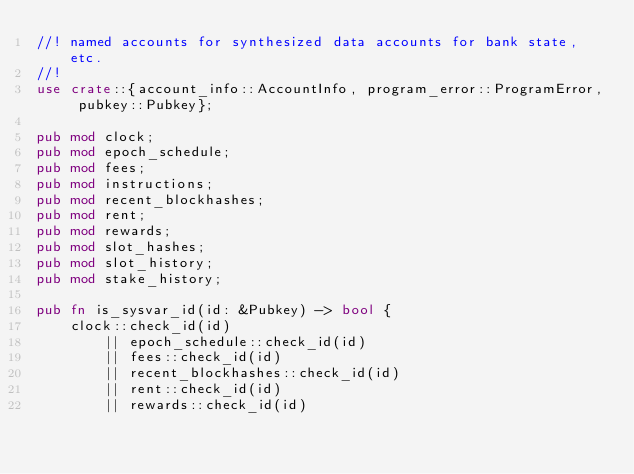<code> <loc_0><loc_0><loc_500><loc_500><_Rust_>//! named accounts for synthesized data accounts for bank state, etc.
//!
use crate::{account_info::AccountInfo, program_error::ProgramError, pubkey::Pubkey};

pub mod clock;
pub mod epoch_schedule;
pub mod fees;
pub mod instructions;
pub mod recent_blockhashes;
pub mod rent;
pub mod rewards;
pub mod slot_hashes;
pub mod slot_history;
pub mod stake_history;

pub fn is_sysvar_id(id: &Pubkey) -> bool {
    clock::check_id(id)
        || epoch_schedule::check_id(id)
        || fees::check_id(id)
        || recent_blockhashes::check_id(id)
        || rent::check_id(id)
        || rewards::check_id(id)</code> 